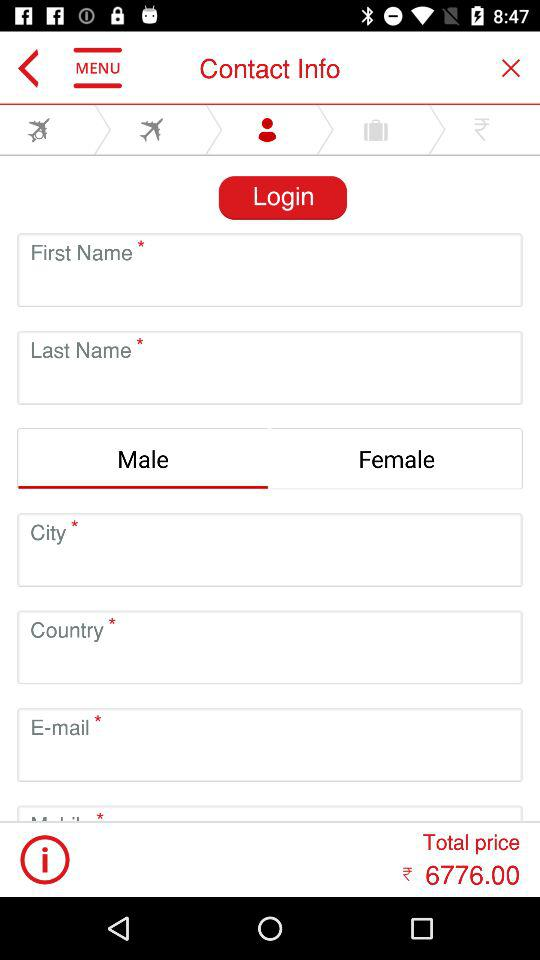What are the available gender options? The available gender options are "Male" and "Female". 